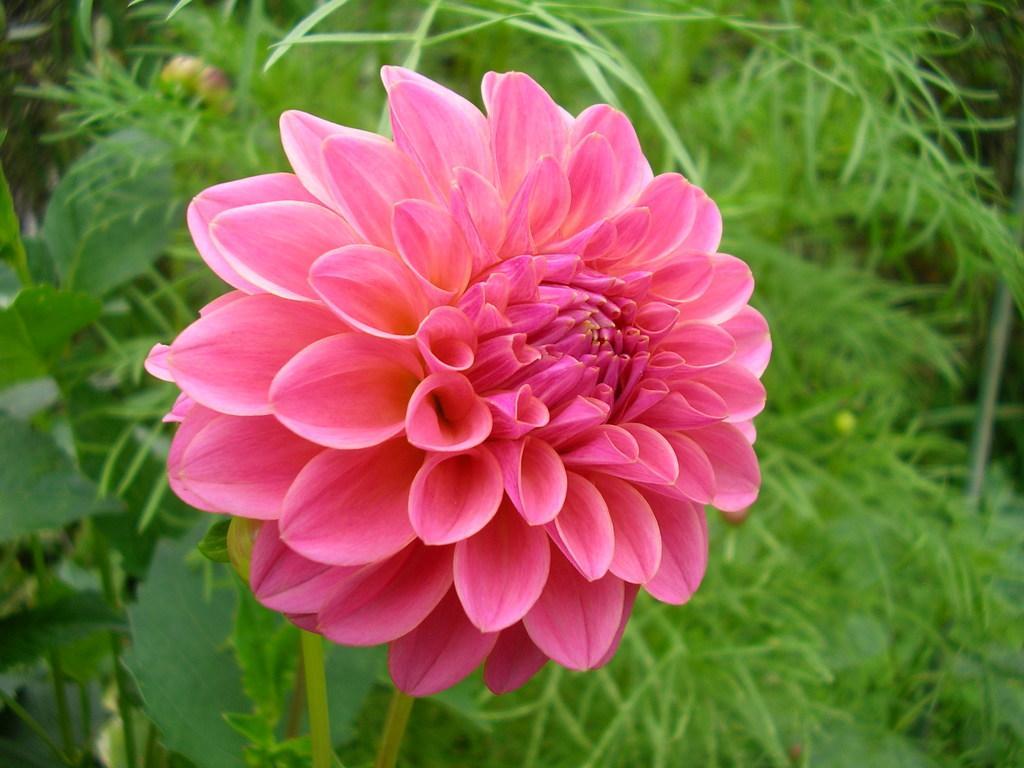Could you give a brief overview of what you see in this image? In this image I can see flower to the plant. The flower is in pink color. 